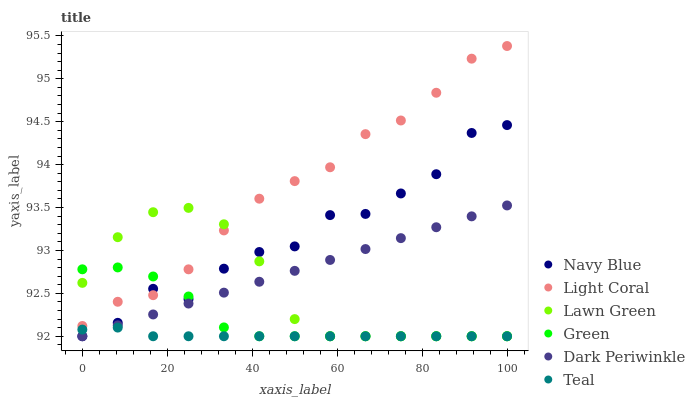Does Teal have the minimum area under the curve?
Answer yes or no. Yes. Does Light Coral have the maximum area under the curve?
Answer yes or no. Yes. Does Navy Blue have the minimum area under the curve?
Answer yes or no. No. Does Navy Blue have the maximum area under the curve?
Answer yes or no. No. Is Dark Periwinkle the smoothest?
Answer yes or no. Yes. Is Navy Blue the roughest?
Answer yes or no. Yes. Is Light Coral the smoothest?
Answer yes or no. No. Is Light Coral the roughest?
Answer yes or no. No. Does Lawn Green have the lowest value?
Answer yes or no. Yes. Does Light Coral have the lowest value?
Answer yes or no. No. Does Light Coral have the highest value?
Answer yes or no. Yes. Does Navy Blue have the highest value?
Answer yes or no. No. Is Dark Periwinkle less than Light Coral?
Answer yes or no. Yes. Is Light Coral greater than Teal?
Answer yes or no. Yes. Does Light Coral intersect Green?
Answer yes or no. Yes. Is Light Coral less than Green?
Answer yes or no. No. Is Light Coral greater than Green?
Answer yes or no. No. Does Dark Periwinkle intersect Light Coral?
Answer yes or no. No. 